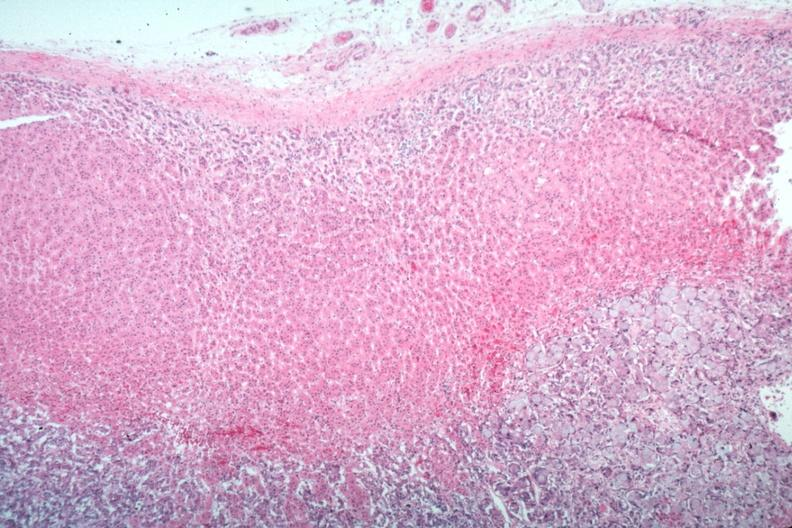s metastatic carcinoma present?
Answer the question using a single word or phrase. Yes 